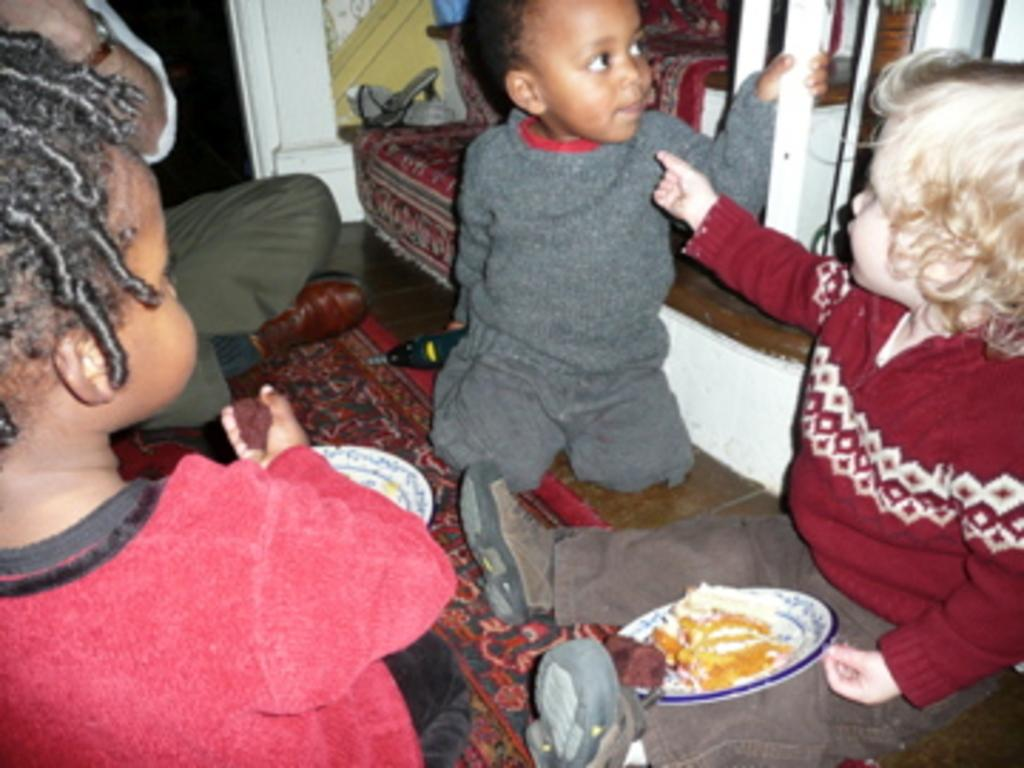How many kids are in the image? There are three kids in the image. What is the person in the image doing? The person is sitting in the image. What can be seen in the background of the image? There is a couch and other objects in the background of the image. What is present in the foreground of the image? There is food on a plate in the foreground of the image. What type of polish is being applied to the quilt in the image? There is no quilt or polish present in the image. 